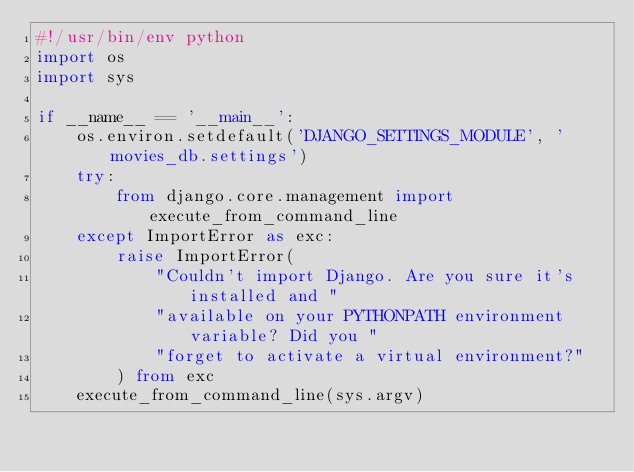<code> <loc_0><loc_0><loc_500><loc_500><_Python_>#!/usr/bin/env python
import os
import sys

if __name__ == '__main__':
    os.environ.setdefault('DJANGO_SETTINGS_MODULE', 'movies_db.settings')
    try:
        from django.core.management import execute_from_command_line
    except ImportError as exc:
        raise ImportError(
            "Couldn't import Django. Are you sure it's installed and "
            "available on your PYTHONPATH environment variable? Did you "
            "forget to activate a virtual environment?"
        ) from exc
    execute_from_command_line(sys.argv)
</code> 